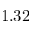<formula> <loc_0><loc_0><loc_500><loc_500>1 . 3 2</formula> 